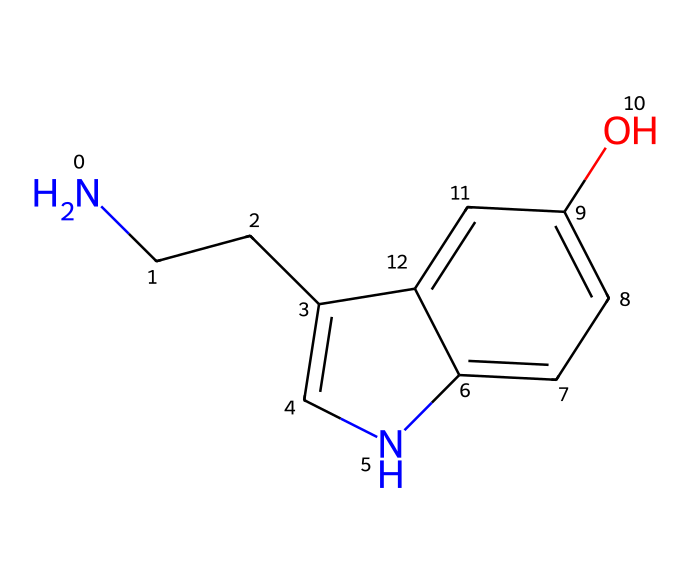What is the molecular formula of serotonin? The chemical structure contains 10 carbon atoms, 12 hydrogen atoms, 1 nitrogen atom, and 1 oxygen atom. Combining these gives the formula C10H12N2O.
Answer: C10H12N2O How many rings are present in the structure of serotonin? Observing the structure revealed two fused cyclic structures. The first ring is a six-membered aromatic ring, and the second is a five-membered ring containing nitrogen. Therefore, there are two rings.
Answer: 2 What functional group is represented by the hydroxyl (-OH) in serotonin? The -OH group present in the structure signifies the presence of a phenolic hydroxyl, meaning it classifies serotonin as a phenolic compound due to the aromatic ring it is attached to.
Answer: phenolic What is the significance of nitrogen in serotonin's structure? The nitrogen atom contributes to the basicity of the molecule and is vital for its function as a neurotransmitter by forming ionic interactions in biological systems, allowing serotonin to bind to its receptors.
Answer: basicity How many chiral centers are present in the serotonin molecule? Analyzing the structure indicates one chiral center at the carbon linked to the amino group. This carbon atom is bonded to four different groups, suggesting its chirality.
Answer: 1 What type of chemical structure does serotonin belong to? Analyzing the structure reveals that it contains both an indole and an ethylamine substructure, classifying serotonin as an indolamine, which is a subtype of biogenic amines.
Answer: indolamine 